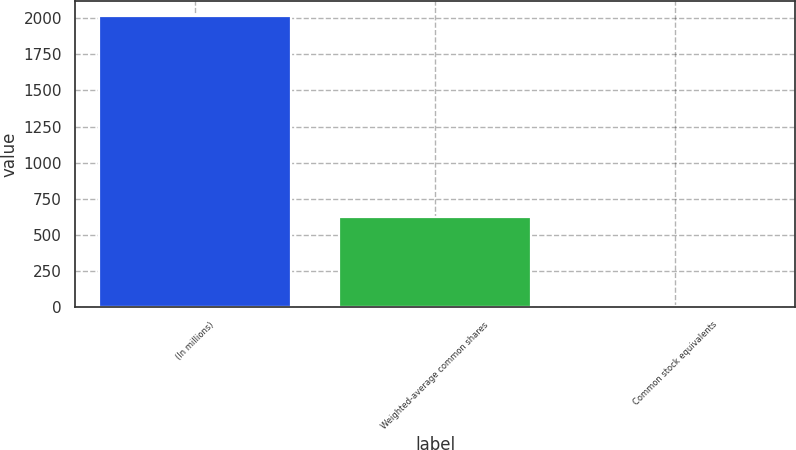Convert chart. <chart><loc_0><loc_0><loc_500><loc_500><bar_chart><fcel>(In millions)<fcel>Weighted-average common shares<fcel>Common stock equivalents<nl><fcel>2017<fcel>623.1<fcel>9<nl></chart> 